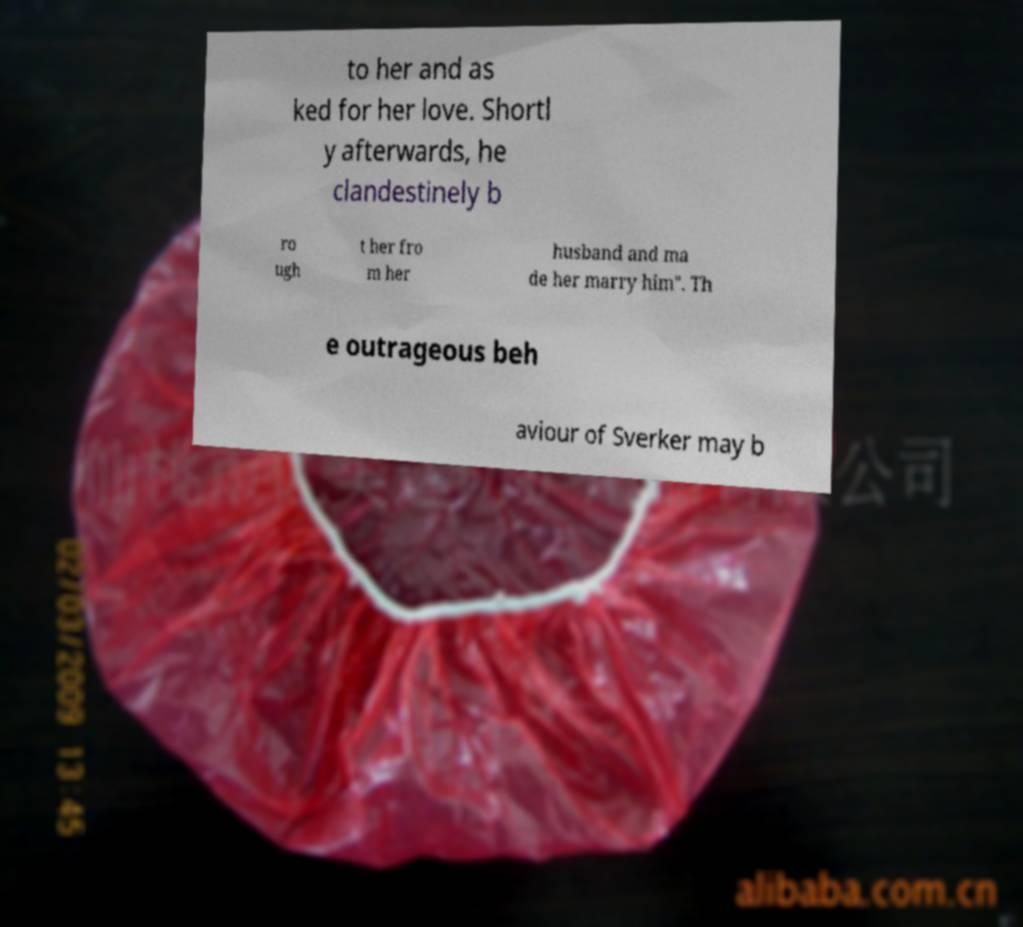Can you read and provide the text displayed in the image?This photo seems to have some interesting text. Can you extract and type it out for me? to her and as ked for her love. Shortl y afterwards, he clandestinely b ro ugh t her fro m her husband and ma de her marry him". Th e outrageous beh aviour of Sverker may b 